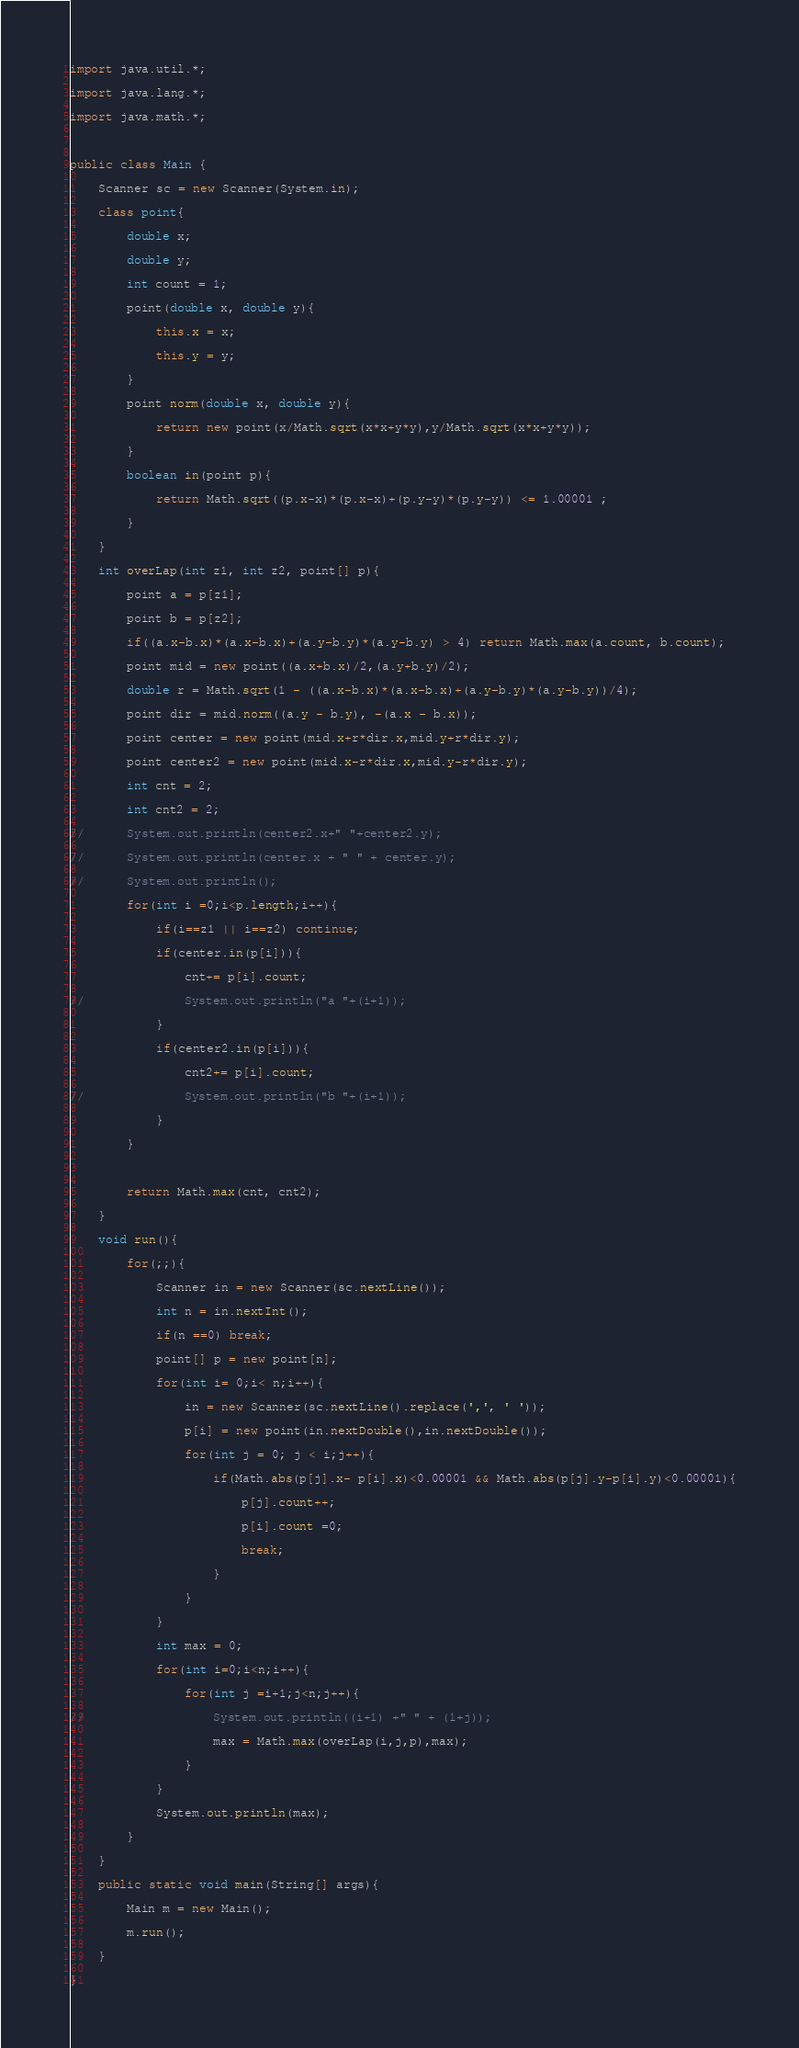Convert code to text. <code><loc_0><loc_0><loc_500><loc_500><_Java_>import java.util.*;

import java.lang.*;

import java.math.*;



public class Main {

	Scanner sc = new Scanner(System.in);

	class point{

		double x;

		double y;

		int count = 1;

		point(double x, double y){

			this.x = x;

			this.y = y;

		}

		point norm(double x, double y){

			return new point(x/Math.sqrt(x*x+y*y),y/Math.sqrt(x*x+y*y));

		}

		boolean in(point p){

			return Math.sqrt((p.x-x)*(p.x-x)+(p.y-y)*(p.y-y)) <= 1.00001 ;

		}

	}

	int overLap(int z1, int z2, point[] p){

		point a = p[z1];

		point b = p[z2];

		if((a.x-b.x)*(a.x-b.x)+(a.y-b.y)*(a.y-b.y) > 4) return Math.max(a.count, b.count);

		point mid = new point((a.x+b.x)/2,(a.y+b.y)/2);

		double r = Math.sqrt(1 - ((a.x-b.x)*(a.x-b.x)+(a.y-b.y)*(a.y-b.y))/4);

		point dir = mid.norm((a.y - b.y), -(a.x - b.x));

		point center = new point(mid.x+r*dir.x,mid.y+r*dir.y); 

		point center2 = new point(mid.x-r*dir.x,mid.y-r*dir.y); 

		int cnt = 2;

		int cnt2 = 2;

//		System.out.println(center2.x+" "+center2.y);

//		System.out.println(center.x + " " + center.y);

//		System.out.println();

		for(int i =0;i<p.length;i++){

			if(i==z1 || i==z2) continue;

			if(center.in(p[i])){

				cnt+= p[i].count;

//				System.out.println("a "+(i+1));

			}

			if(center2.in(p[i])){

				cnt2+= p[i].count;

//				System.out.println("b "+(i+1));

			}

		}

		

		return Math.max(cnt, cnt2);

	}

	void run(){

		for(;;){

			Scanner in = new Scanner(sc.nextLine());

			int n = in.nextInt();

			if(n ==0) break;

			point[] p = new point[n];

			for(int i= 0;i< n;i++){

				in = new Scanner(sc.nextLine().replace(',', ' '));

				p[i] = new point(in.nextDouble(),in.nextDouble());

				for(int j = 0; j < i;j++){

					if(Math.abs(p[j].x- p[i].x)<0.00001 && Math.abs(p[j].y-p[i].y)<0.00001){

						p[j].count++;

						p[i].count =0;

						break;

					}

				}

			}

			int max = 0;

			for(int i=0;i<n;i++){

				for(int j =i+1;j<n;j++){

//					System.out.println((i+1) +" " + (1+j));

					max = Math.max(overLap(i,j,p),max);

				}

			}

			System.out.println(max);

		}

	}

	public static void main(String[] args){

		Main m = new Main();

		m.run();

	}

}</code> 